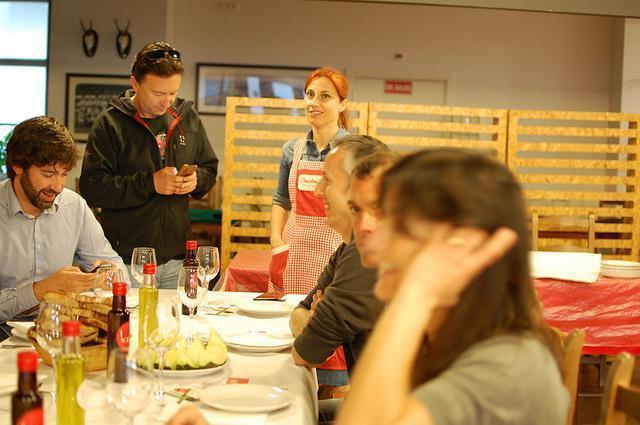How many people are in the photo?
Give a very brief answer. 6. How many wine glasses are there?
Give a very brief answer. 2. How many dining tables are there?
Give a very brief answer. 2. How many bottles are there?
Give a very brief answer. 2. 